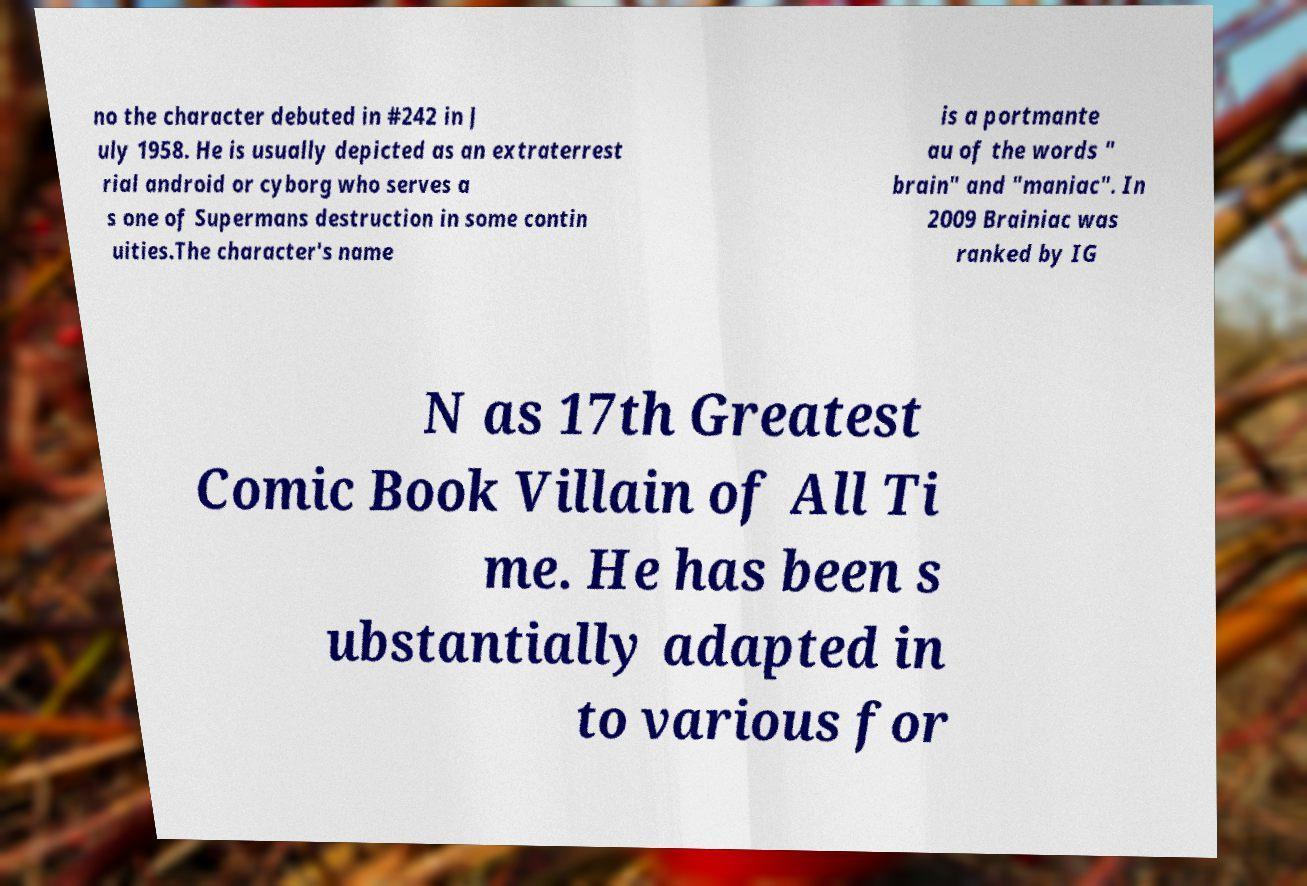Could you assist in decoding the text presented in this image and type it out clearly? no the character debuted in #242 in J uly 1958. He is usually depicted as an extraterrest rial android or cyborg who serves a s one of Supermans destruction in some contin uities.The character's name is a portmante au of the words " brain" and "maniac". In 2009 Brainiac was ranked by IG N as 17th Greatest Comic Book Villain of All Ti me. He has been s ubstantially adapted in to various for 